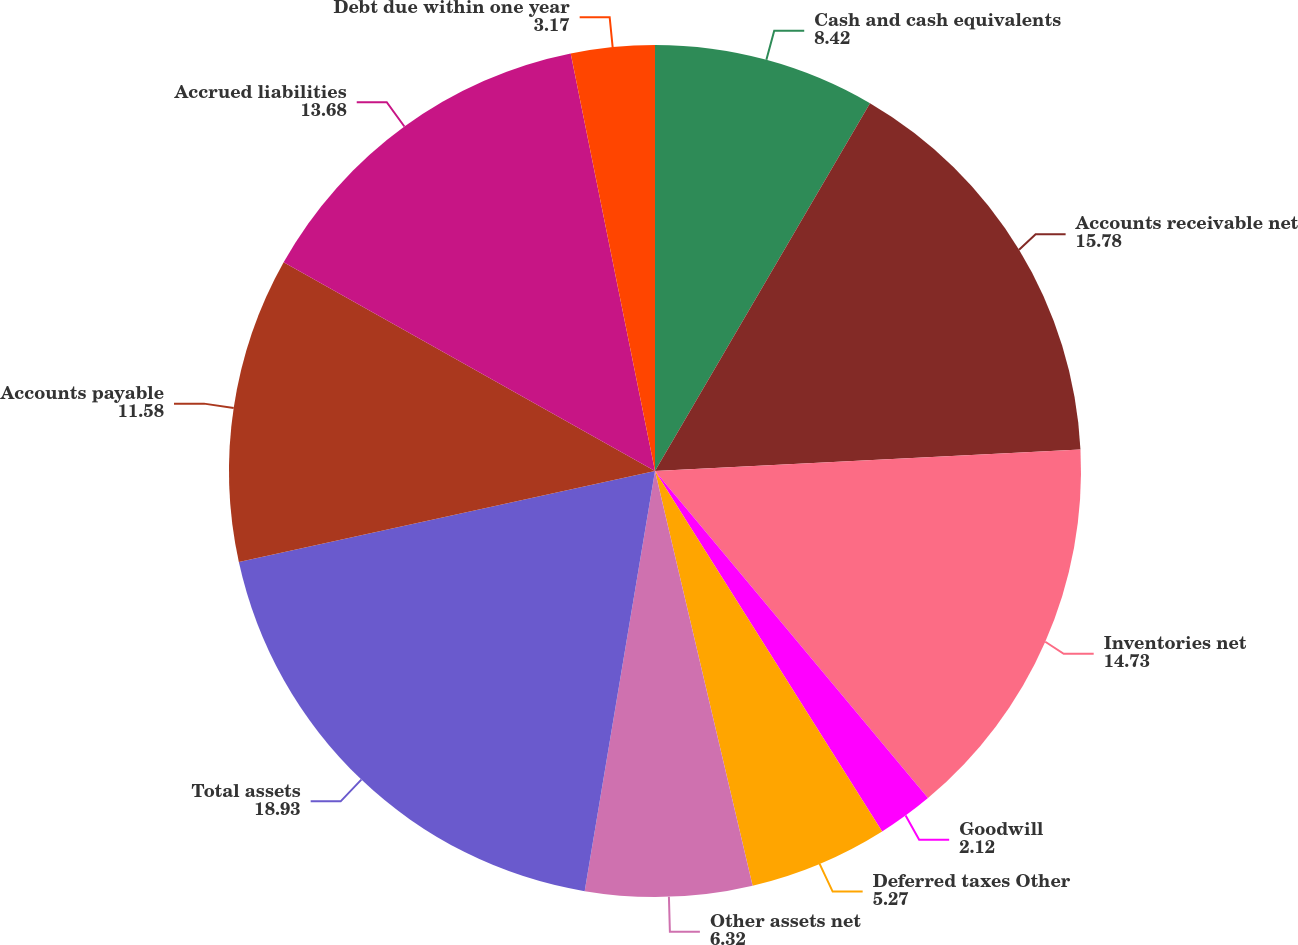<chart> <loc_0><loc_0><loc_500><loc_500><pie_chart><fcel>Cash and cash equivalents<fcel>Accounts receivable net<fcel>Inventories net<fcel>Goodwill<fcel>Deferred taxes Other<fcel>Other assets net<fcel>Total assets<fcel>Accounts payable<fcel>Accrued liabilities<fcel>Debt due within one year<nl><fcel>8.42%<fcel>15.78%<fcel>14.73%<fcel>2.12%<fcel>5.27%<fcel>6.32%<fcel>18.93%<fcel>11.58%<fcel>13.68%<fcel>3.17%<nl></chart> 